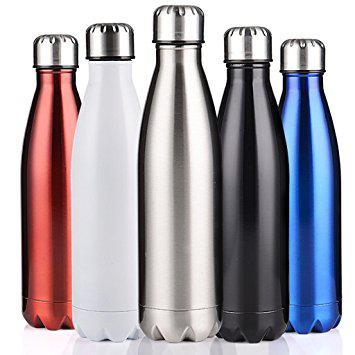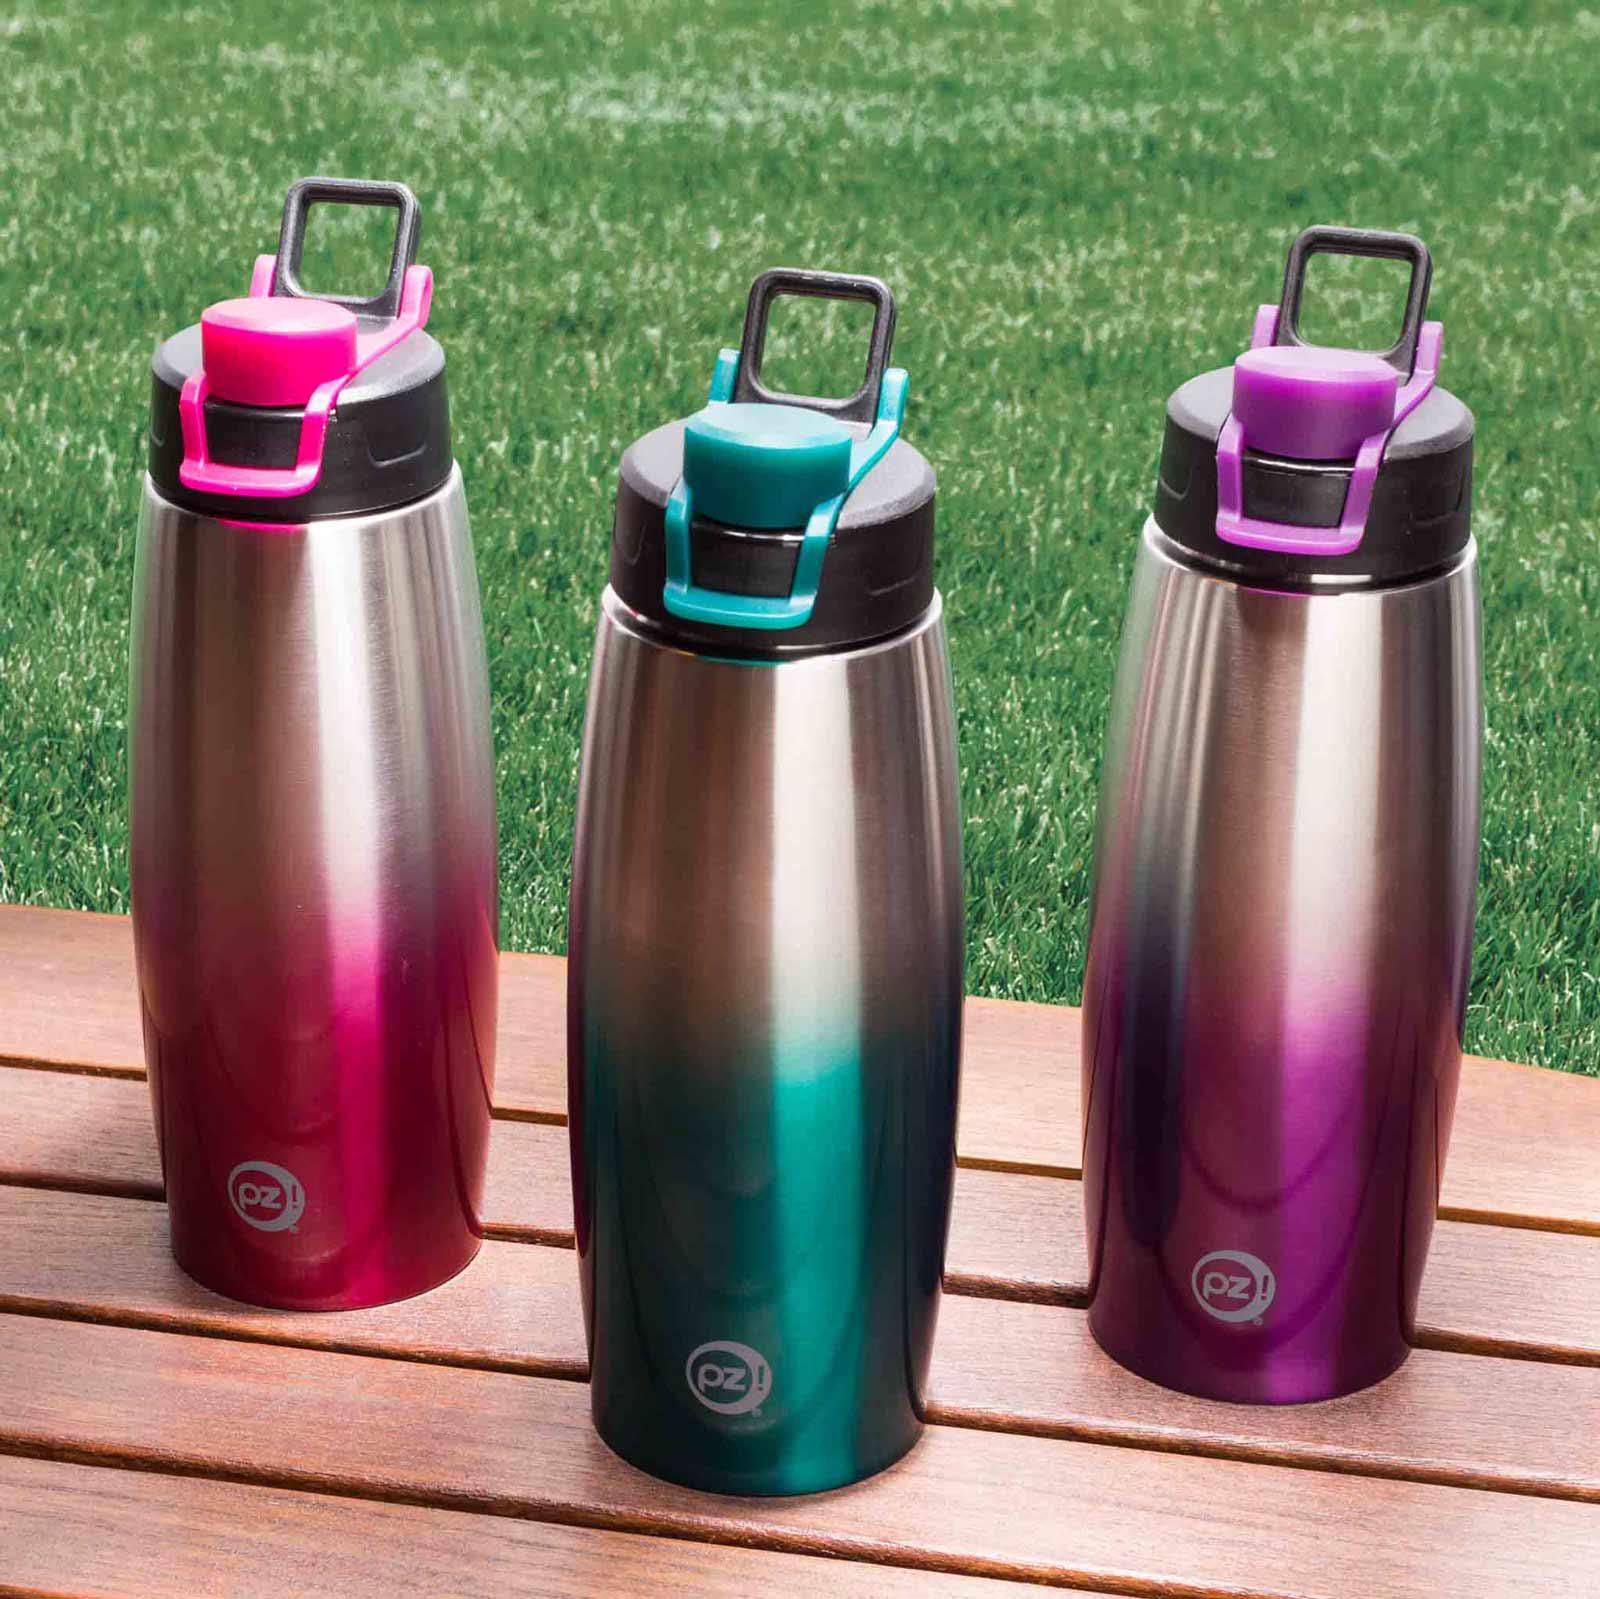The first image is the image on the left, the second image is the image on the right. For the images shown, is this caption "In one image, five bottles with chrome caps and dimpled bottom sections are the same design, but in different colors" true? Answer yes or no. Yes. The first image is the image on the left, the second image is the image on the right. For the images shown, is this caption "The bottles in one of the images are sitting outside." true? Answer yes or no. Yes. 